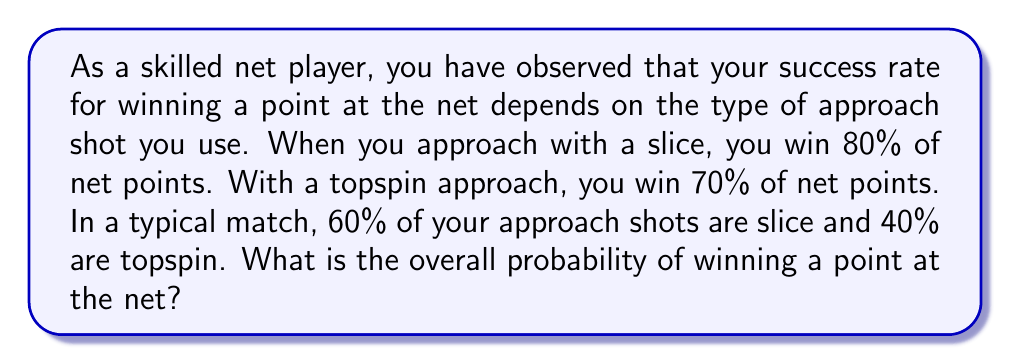Give your solution to this math problem. Let's approach this step-by-step using the law of total probability:

1) Define events:
   S: Slice approach
   T: Topspin approach
   W: Winning the point at the net

2) Given probabilities:
   P(S) = 0.60 (60% of approaches are slice)
   P(T) = 0.40 (40% of approaches are topspin)
   P(W|S) = 0.80 (80% win rate with slice approach)
   P(W|T) = 0.70 (70% win rate with topspin approach)

3) Law of Total Probability:
   P(W) = P(W|S) * P(S) + P(W|T) * P(T)

4) Substitute the values:
   P(W) = 0.80 * 0.60 + 0.70 * 0.40

5) Calculate:
   P(W) = 0.48 + 0.28 = 0.76

Therefore, the overall probability of winning a point at the net is 0.76 or 76%.
Answer: 0.76 